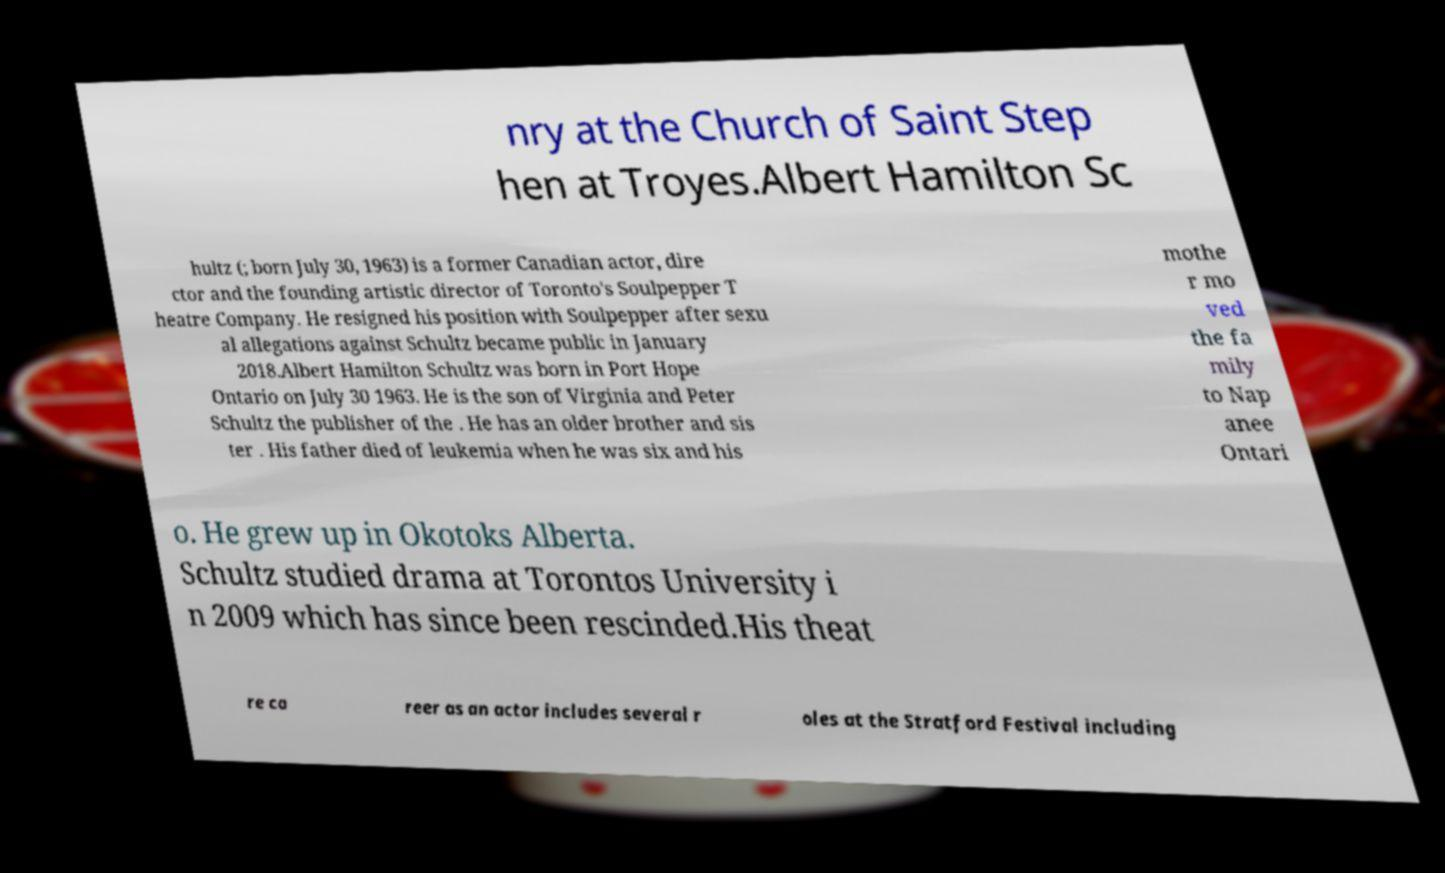Can you accurately transcribe the text from the provided image for me? nry at the Church of Saint Step hen at Troyes.Albert Hamilton Sc hultz (; born July 30, 1963) is a former Canadian actor, dire ctor and the founding artistic director of Toronto's Soulpepper T heatre Company. He resigned his position with Soulpepper after sexu al allegations against Schultz became public in January 2018.Albert Hamilton Schultz was born in Port Hope Ontario on July 30 1963. He is the son of Virginia and Peter Schultz the publisher of the . He has an older brother and sis ter . His father died of leukemia when he was six and his mothe r mo ved the fa mily to Nap anee Ontari o. He grew up in Okotoks Alberta. Schultz studied drama at Torontos University i n 2009 which has since been rescinded.His theat re ca reer as an actor includes several r oles at the Stratford Festival including 